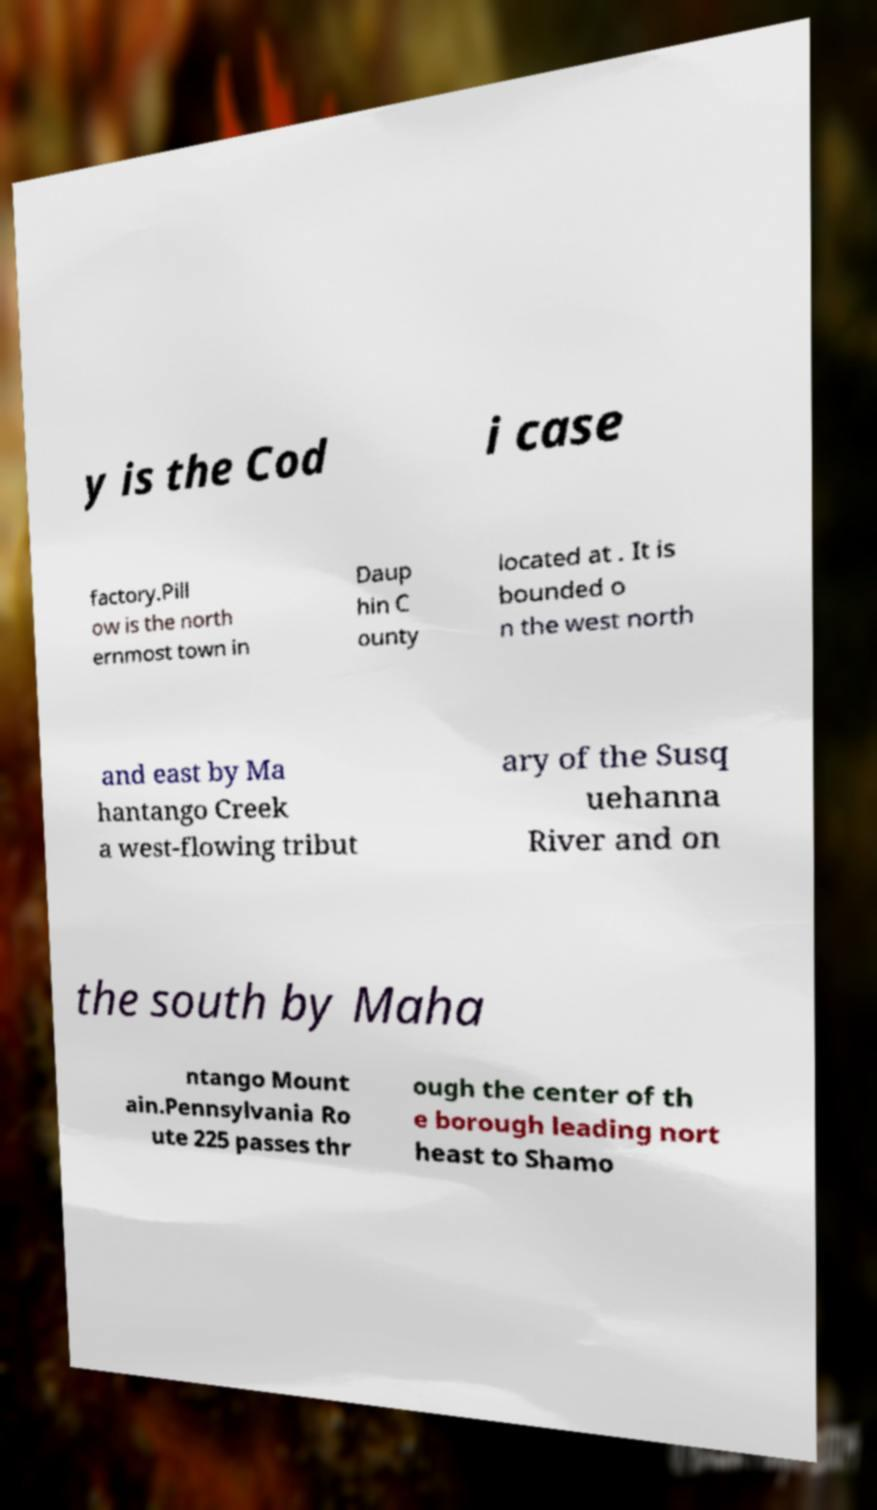Could you extract and type out the text from this image? y is the Cod i case factory.Pill ow is the north ernmost town in Daup hin C ounty located at . It is bounded o n the west north and east by Ma hantango Creek a west-flowing tribut ary of the Susq uehanna River and on the south by Maha ntango Mount ain.Pennsylvania Ro ute 225 passes thr ough the center of th e borough leading nort heast to Shamo 